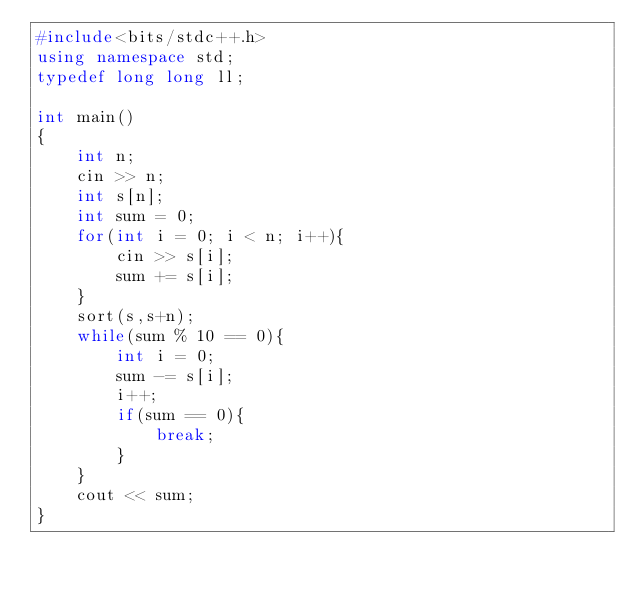Convert code to text. <code><loc_0><loc_0><loc_500><loc_500><_C++_>#include<bits/stdc++.h>
using namespace std;
typedef long long ll;

int main()
{
    int n;
    cin >> n;
    int s[n];
    int sum = 0;
    for(int i = 0; i < n; i++){
        cin >> s[i];
        sum += s[i];
    }
    sort(s,s+n);
    while(sum % 10 == 0){
        int i = 0;
        sum -= s[i];
        i++;
        if(sum == 0){
            break;
        }
    }
    cout << sum;
}</code> 